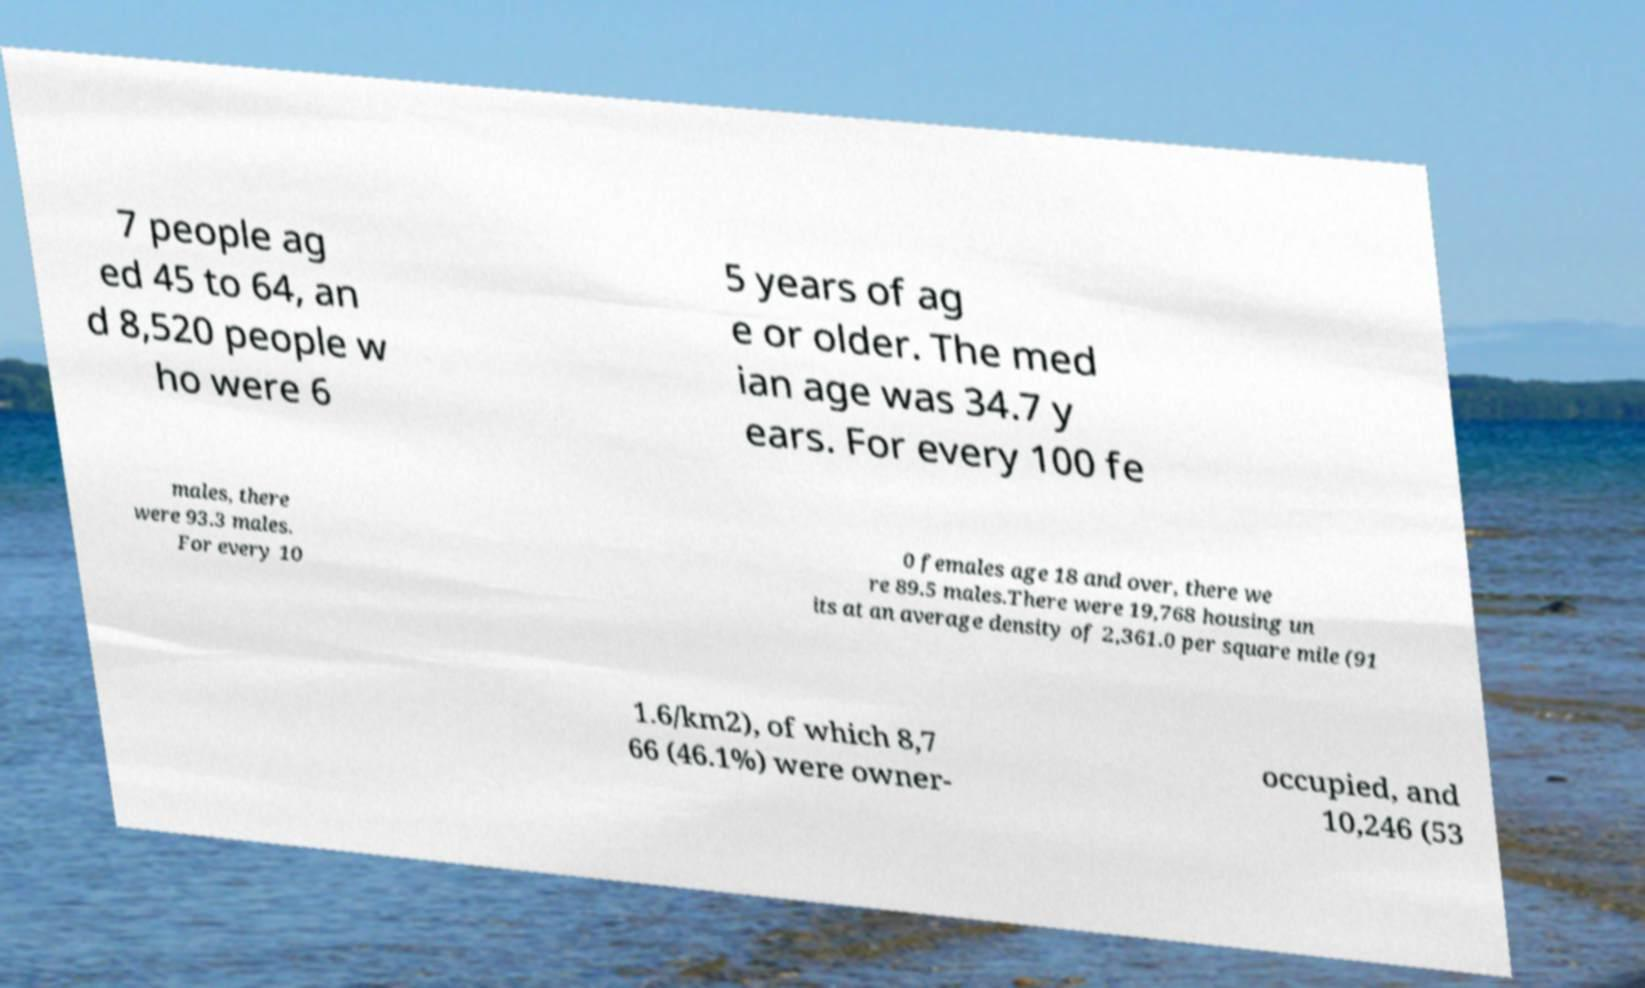Could you assist in decoding the text presented in this image and type it out clearly? 7 people ag ed 45 to 64, an d 8,520 people w ho were 6 5 years of ag e or older. The med ian age was 34.7 y ears. For every 100 fe males, there were 93.3 males. For every 10 0 females age 18 and over, there we re 89.5 males.There were 19,768 housing un its at an average density of 2,361.0 per square mile (91 1.6/km2), of which 8,7 66 (46.1%) were owner- occupied, and 10,246 (53 